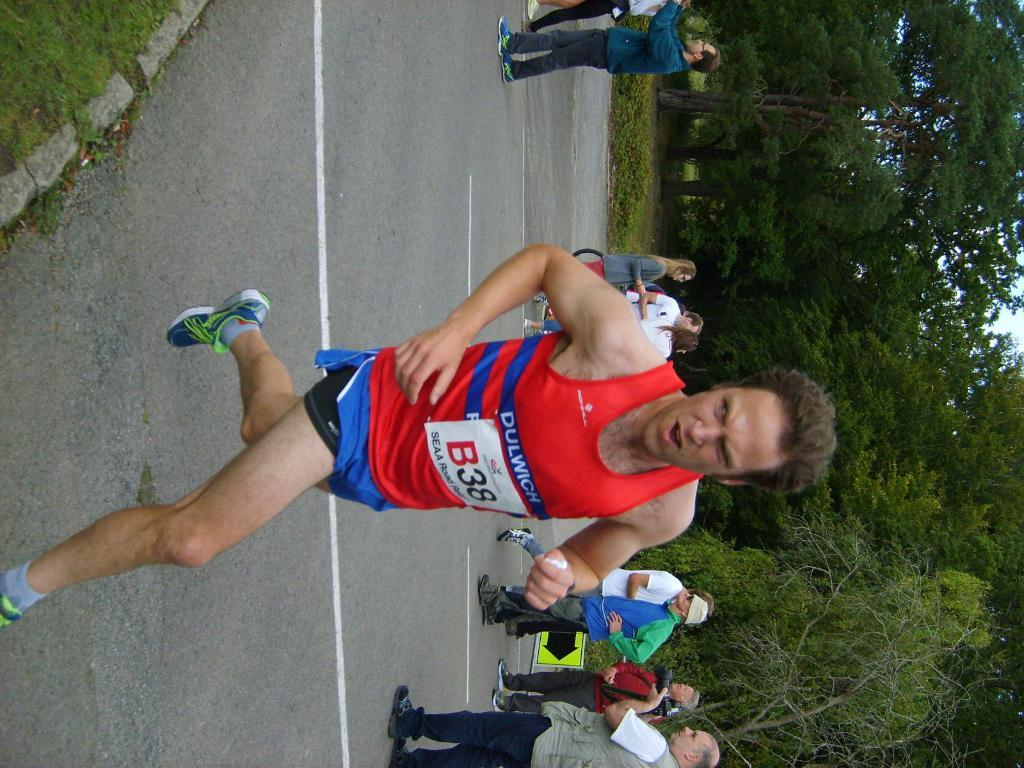What is the man in the image doing? The man is running in the image. What are the other people in the image doing? There is a group of people standing in the image. What object can be seen in the image besides the people? There is a board in the image. What can be seen in the background of the image? There are trees in the background of the image. How does the bucket help the growth of the trees in the image? There is no bucket present in the image, and therefore no such assistance can be observed. 